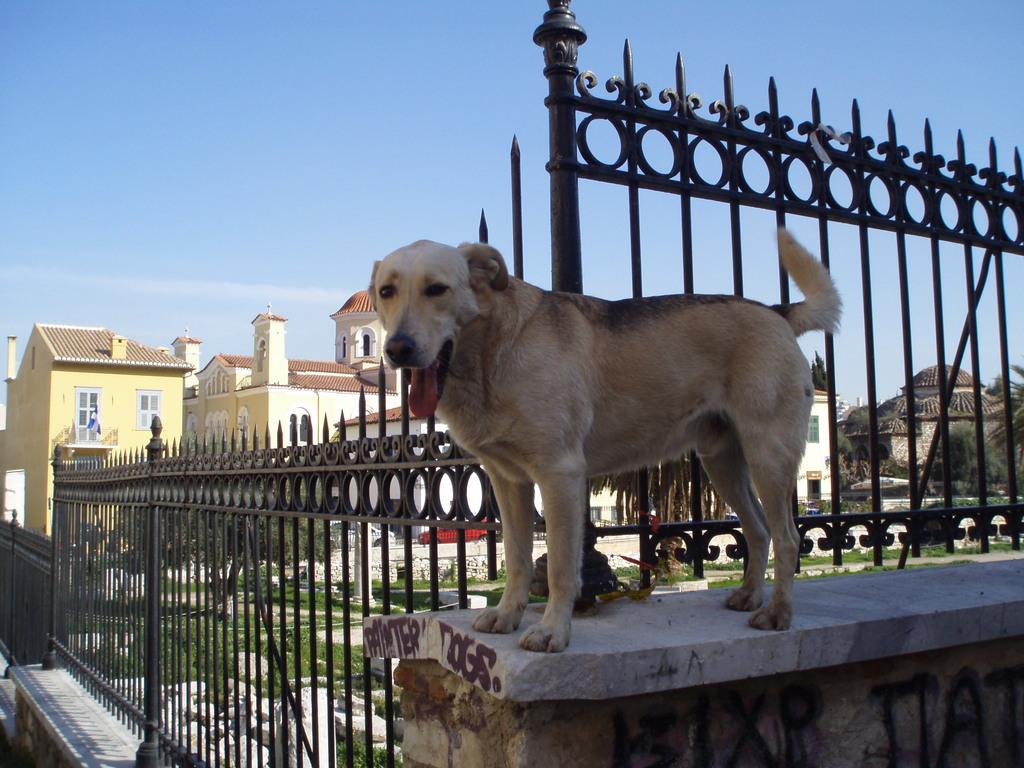What animal can be seen on a wall in the image? There is a dog on a wall in the image. What type of structure is near the wall in the image? There are railings near the wall in the image. What can be seen in the background of the image? There are buildings with windows in the background of the image, and the sky is also visible. What type of leather is being used to create the dog's fur in the image? The image is a photograph, and the dog is a real animal, so there is no leather used to create the dog's fur in the image. 